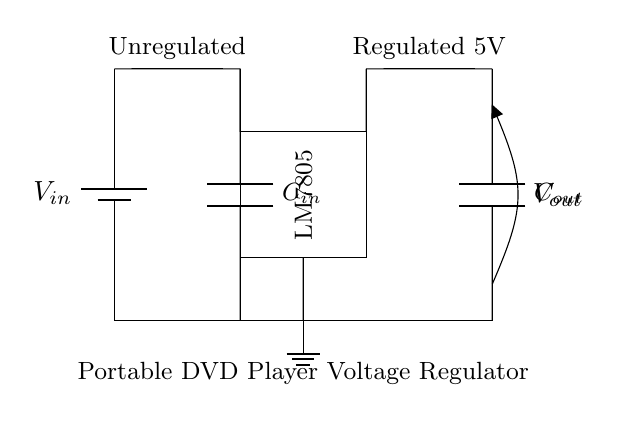What is the input voltage in the circuit? The input voltage is indicated as \( V_{in} \) in the diagram and is supplied by the battery.
Answer: V_in Which component regulates the voltage in this circuit? The component that regulates the voltage is labeled as LM7805, which is a voltage regulator IC responsible for maintaining output voltage at a specified level.
Answer: LM7805 What is the output voltage generated by this circuit? The output voltage is clearly labeled as \( V_{out} \) and is regulated to 5V by the voltage regulator.
Answer: 5V What is the function of capacitor \( C_{in} \) in this circuit? Capacitor \( C_{in} \) is used for smoothing out the input voltage from the battery before it reaches the voltage regulator, helping to filter any fluctuations.
Answer: Smoothing How many capacitors are present in the circuit? The diagram shows two capacitors: \( C_{in} \) and \( C_{out} \), indicating the number of capacitors connected in the circuit.
Answer: Two What is the ground connection represented by in the diagram? The ground connection is represented by a symbol labeled as ground, indicating the reference point for the circuit where all voltages are measured relative to.
Answer: Ground What type of circuit is this diagram an example of? This circuit is an example of a voltage regulation circuit designed to provide stable output voltage for electronic devices such as a portable DVD player.
Answer: Voltage regulation circuit 